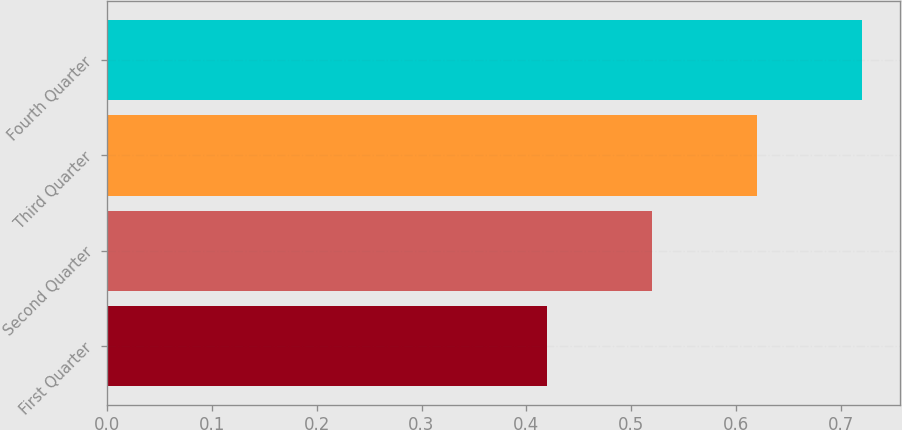<chart> <loc_0><loc_0><loc_500><loc_500><bar_chart><fcel>First Quarter<fcel>Second Quarter<fcel>Third Quarter<fcel>Fourth Quarter<nl><fcel>0.42<fcel>0.52<fcel>0.62<fcel>0.72<nl></chart> 